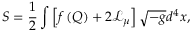Convert formula to latex. <formula><loc_0><loc_0><loc_500><loc_500>S = \frac { 1 } { 2 } \int \left [ f \left ( Q \right ) + { 2 \mathcal { L } _ { \mu } } \right ] \sqrt { - g } d ^ { 4 } x ,</formula> 